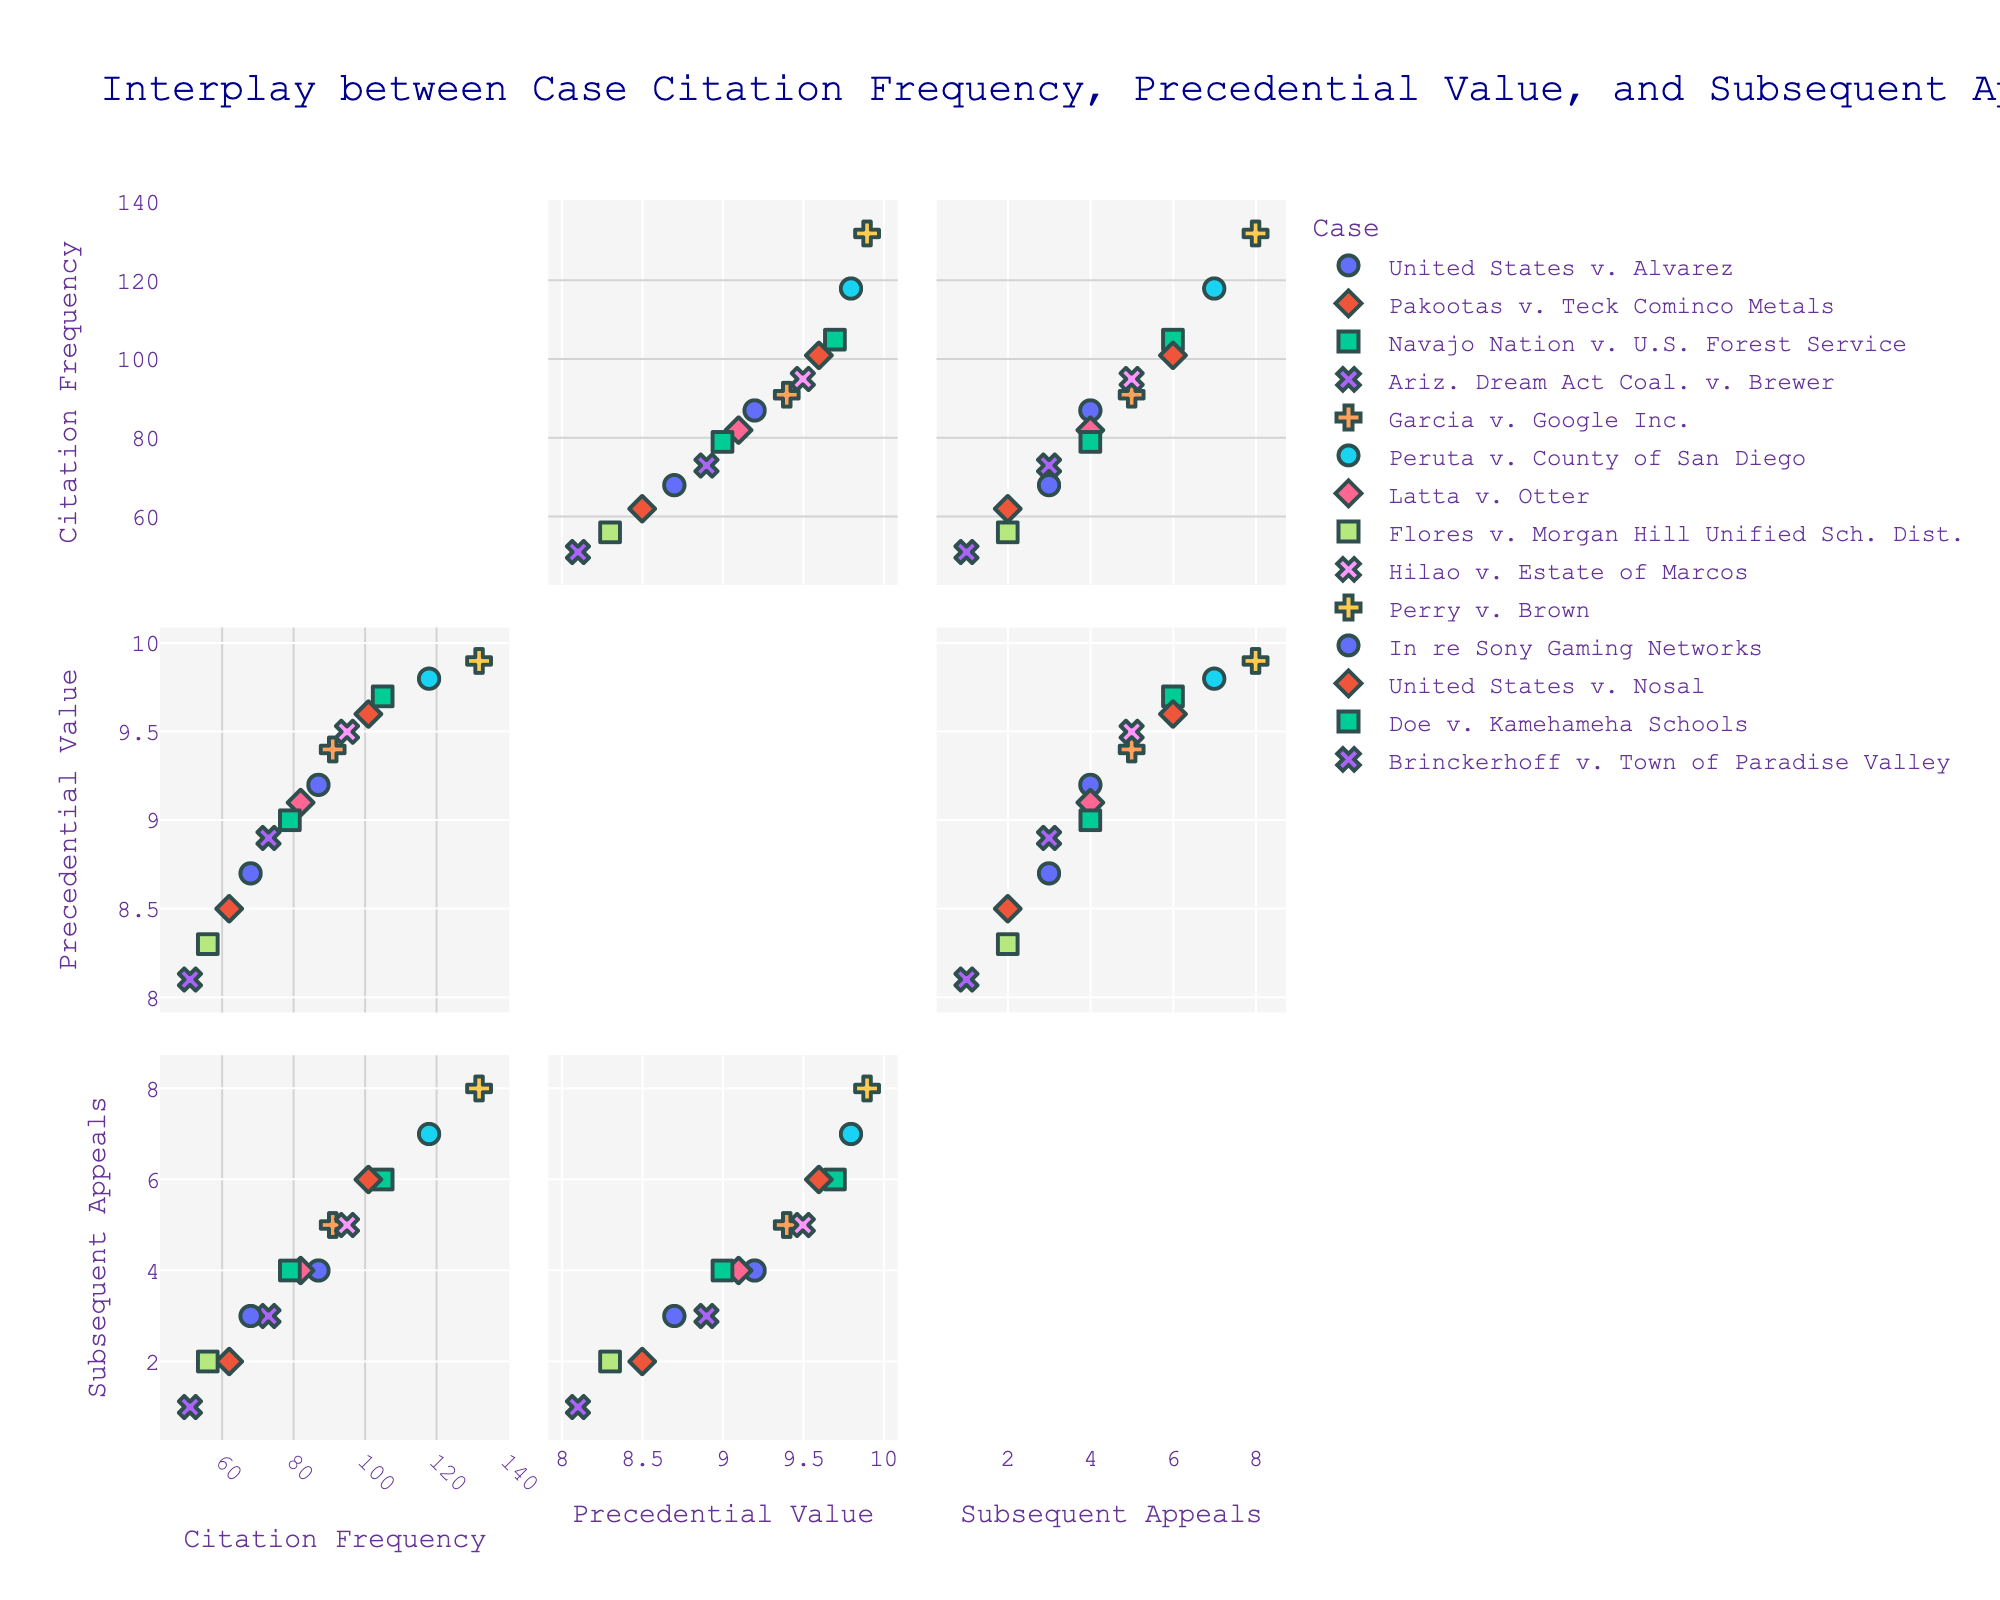what is the title of the scatterplot matrix? The title of the scatterplot matrix is displayed at the top of the plot. It should describe the content and purpose of the plot. By looking at the figure, we can find that the title is "Interplay between Case Citation Frequency, Precedential Value, and Subsequent Appeals".
Answer: Interplay between Case Citation Frequency, Precedential Value, and Subsequent Appeals how many data points are included in the figure? To determine the number of data points in the scatterplot matrix, we can count the number of unique cases listed in the dataset. According to the data, there are 14 cases. Thus, there should be 14 data points in the figure.
Answer: 14 which case has the highest citation frequency? To find the case with the highest citation frequency, we need to identify the data point with the highest value on the Citation Frequency axis. Referring to the data, "Perry v. Brown" has the highest citation frequency of 132.
Answer: Perry v. Brown which cases have both citation frequency greater than 100 and precedential value greater than 9.5? For this question, we look for data points that satisfy both conditions: citation frequency > 100 and precedential value > 9.5. According to the data, "Perry v. Brown" (132, 9.9), "Peruta v. County of San Diego" (118, 9.8) and "Navajo Nation v. U.S. Forest Service" (105, 9.7) meet these criteria.
Answer: Perry v. Brown, Peruta v. County of San Diego, Navajo Nation v. U.S. Forest Service compare the number of subsequent appeals for the cases with the lowest and highest precedential values First, identify the cases with the lowest and highest precedential values from the data: "Brinckerhoff v. Town of Paradise Valley" (8.1) has the lowest value, and "Perry v. Brown" (9.9) has the highest. Then, compare their subsequent appeals, which are 1 and 8, respectively.
Answer: The lowest precedential value case has 1 subsequent appeal, and the highest precedential value case has 8 subsequent appeals is there a visible correlation between precedential value and subsequent appeals? To determine whether there is a visible correlation between precedential value and subsequent appeals, we can observe the pattern of the data points in the scatterplot matrix. Typically, a positive or negative trend indicates a correlation. The scatterplot suggests a positive correlation, meaning that higher precedential values tend to be associated with more subsequent appeals.
Answer: Yes, a positive correlation which cases have the same number of subsequent appeals? To find the cases with the same number of subsequent appeals, we look for duplicated values in the Subsequent Appeals column. "United States v. Alvarez" and "Latta v. Otter" both have 4 subsequent appeals, "Doe v. Kamehameha Schools" and "Ariz. Dream Act Coal. v. Brewer" have 3, "Hilao v. Estate of Marcos" and "Garcia v. Google Inc." have 5, and "Pakootas v. Teck Cominco Metals" and "Flores v. Morgan Hill Unified Sch. Dist." have 2.
Answer: United States v. Alvarez and Latta v. Otter; Doe v. Kamehameha Schools and Ariz. Dream Act Coal. v. Brewer; Hilao v. Estate of Marcos and Garcia v. Google Inc.; Pakootas v. Teck Cominco Metals and Flores v. Morgan Hill Unified Sch. Dist what is the overall distribution of citation frequencies across the cases? By examining the data points on the Citation Frequency axis, we can describe the distribution. The citation frequencies range from 51 to 132. Most values are clustered between 60 and 100, with a few cases having higher than 100 citation frequencies.
Answer: Clustered between 60 and 100, with a few above 100 do cases with higher precedential value tend to have higher citation frequency? To determine this, we can observe the relationship between citation frequency and precedential value in the scatterplot matrix. If most data points with high precedential values also have high citation frequencies, this indicates a positive trend. The scatterplot suggests that cases with higher precedential values tend to have higher citation frequencies.
Answer: Yes compare the precedential value of "Garcia v. Google Inc." and "Doe v. Kamehameha Schools" Looking at the precedential values for "Garcia v. Google Inc." and "Doe v. Kamehameha Schools" from the data, we can directly compare the values. "Garcia v. Google Inc." has a precedential value of 9.4, and "Doe v. Kamehameha Schools" has a precedential value of 9.0.
Answer: Garcia v. Google Inc.: 9.4, Doe v. Kamehameha Schools: 9.0 